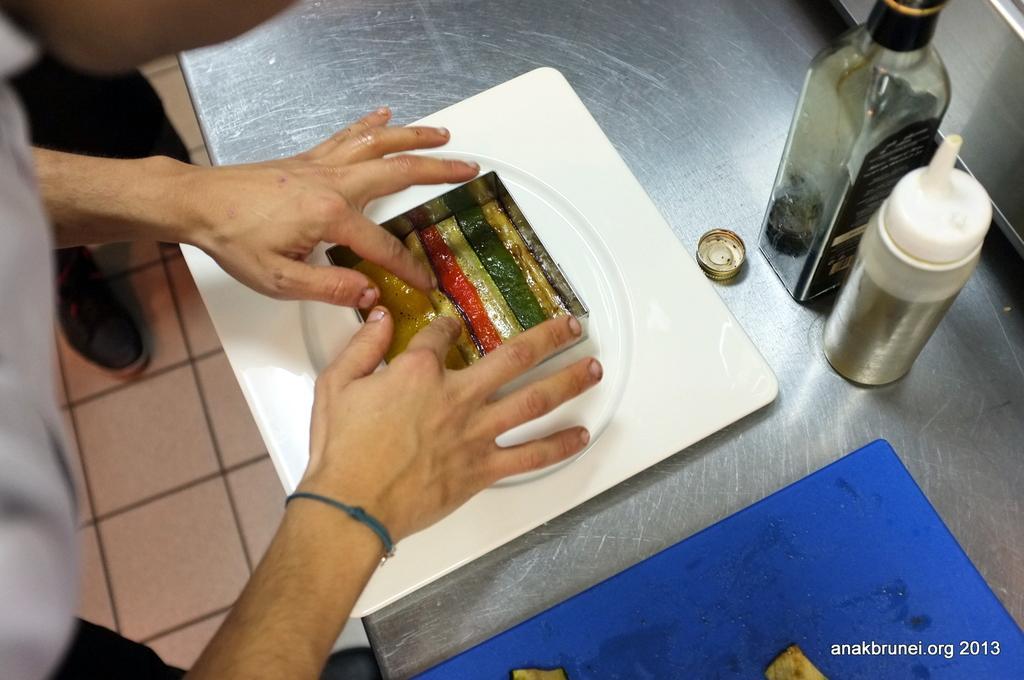Describe this image in one or two sentences. A man is making the food in the plate with his hands. 